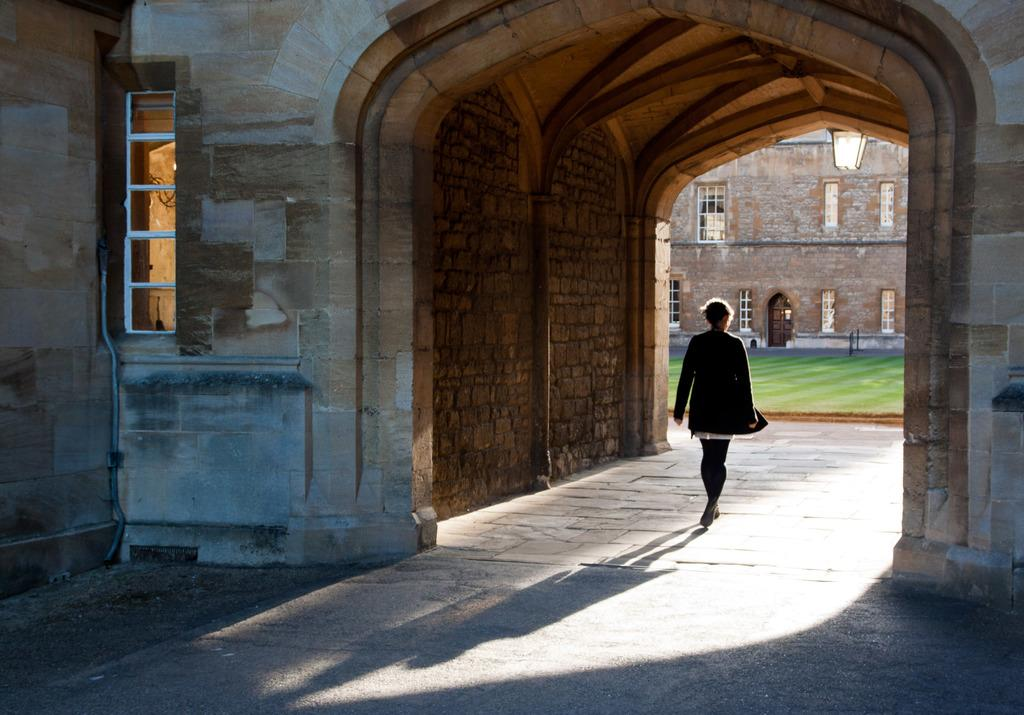What is the person in the image doing? There is a person walking in the image. What can be seen in the background of the image? There is a wall, grass, at least one building, and windows visible in the background of the image. What trade agreement is the minister discussing with the person in the image? There is no minister or discussion of trade agreements present in the image. 